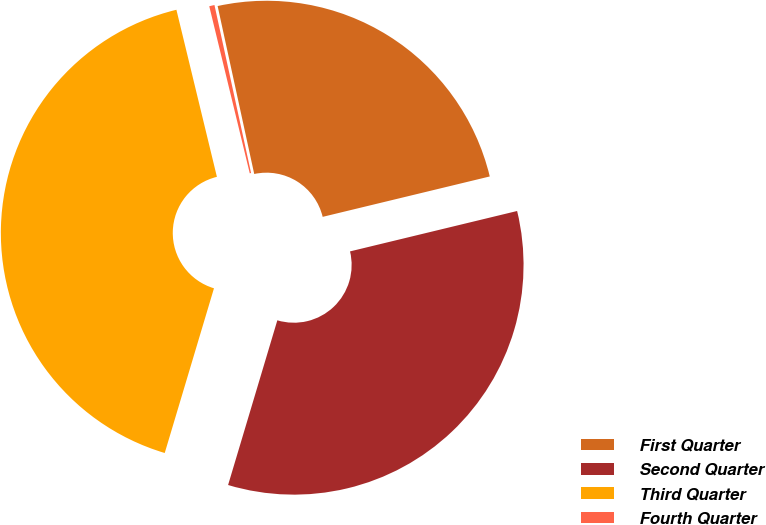Convert chart. <chart><loc_0><loc_0><loc_500><loc_500><pie_chart><fcel>First Quarter<fcel>Second Quarter<fcel>Third Quarter<fcel>Fourth Quarter<nl><fcel>24.64%<fcel>33.4%<fcel>41.59%<fcel>0.37%<nl></chart> 